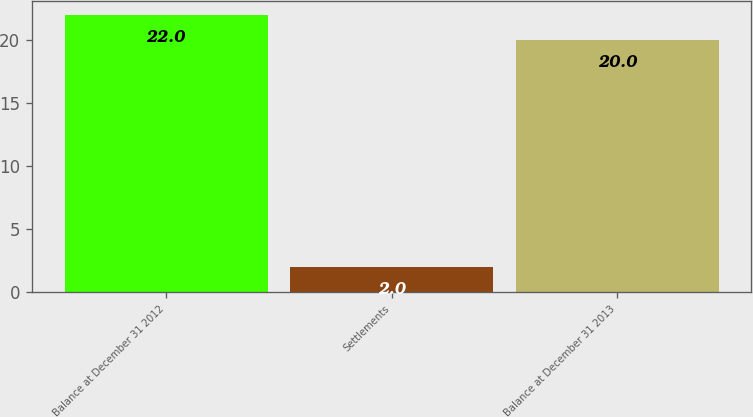Convert chart to OTSL. <chart><loc_0><loc_0><loc_500><loc_500><bar_chart><fcel>Balance at December 31 2012<fcel>Settlements<fcel>Balance at December 31 2013<nl><fcel>22<fcel>2<fcel>20<nl></chart> 